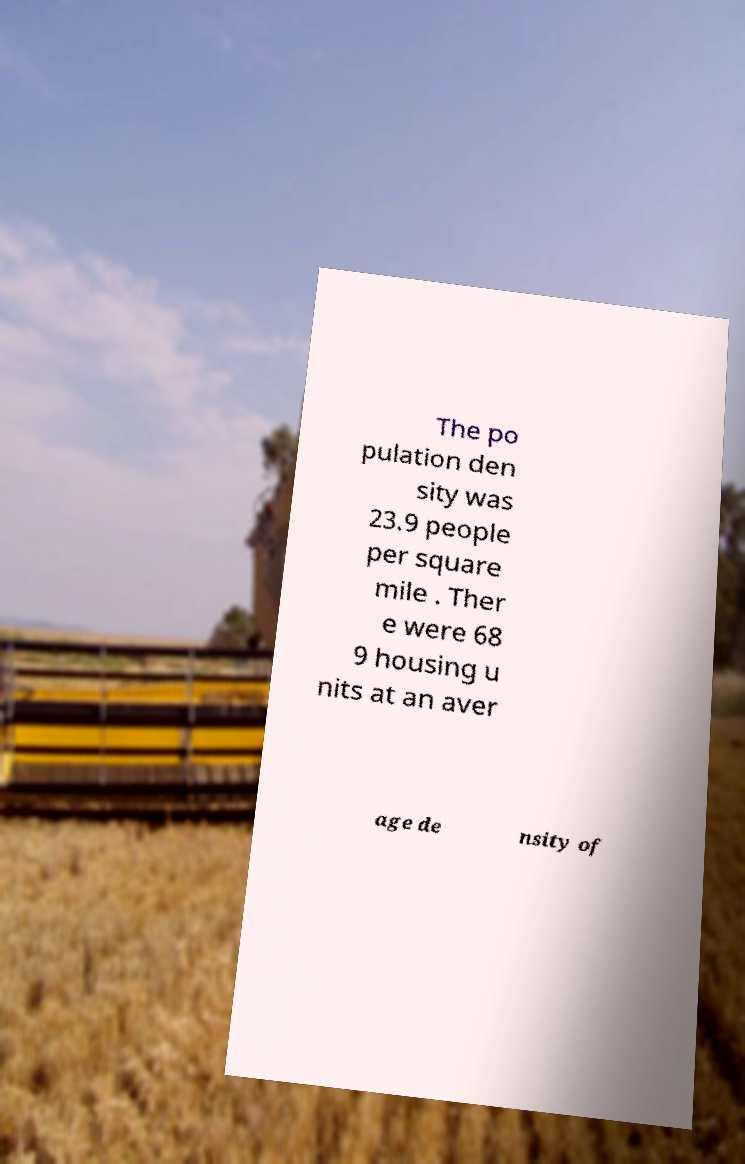For documentation purposes, I need the text within this image transcribed. Could you provide that? The po pulation den sity was 23.9 people per square mile . Ther e were 68 9 housing u nits at an aver age de nsity of 